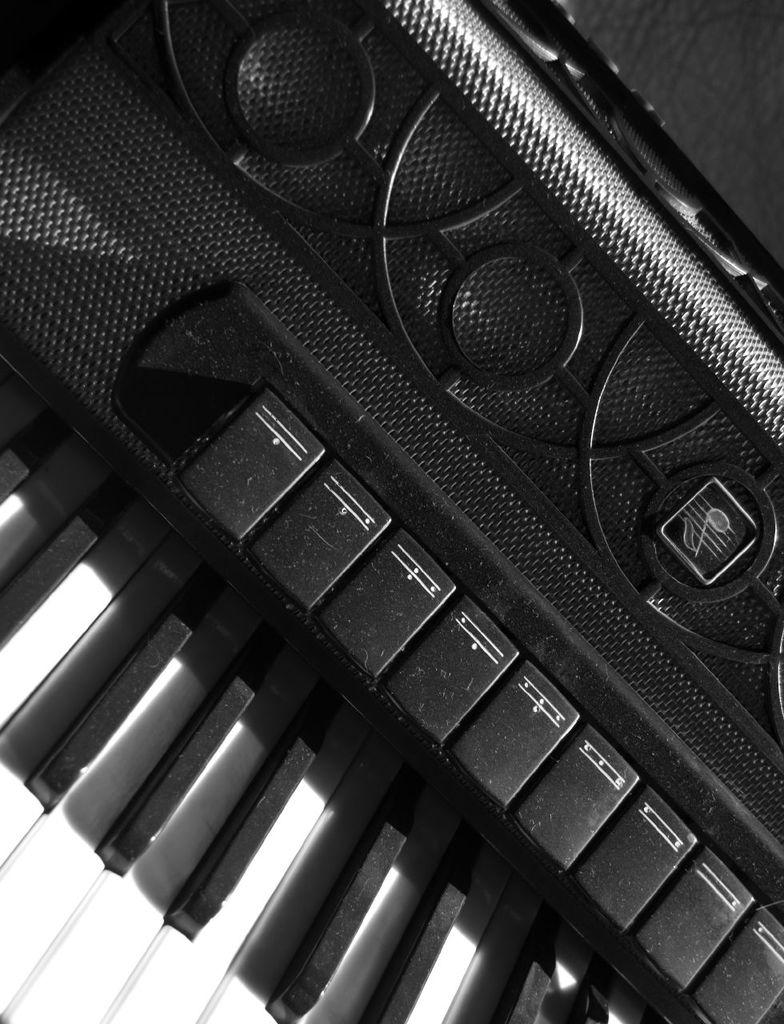What is the main object in the image? There is a piano in the image. Where is the coat hanging in the image? There is no coat present in the image. What type of lumber is being used to build the piano in the image? The image does not show the construction of the piano, so it is not possible to determine what type of lumber might have been used. 